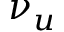<formula> <loc_0><loc_0><loc_500><loc_500>\nu _ { u }</formula> 